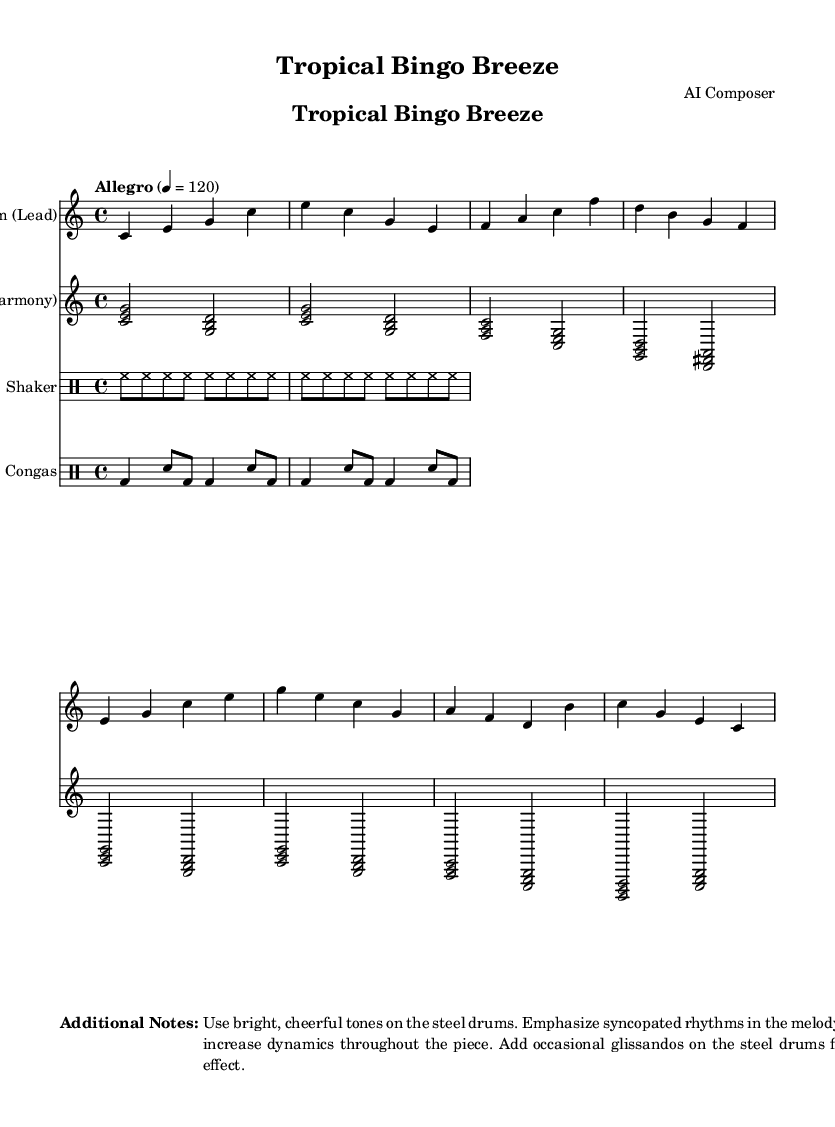What is the key signature of this music? The key signature is indicated at the beginning of the piece, which shows no sharps or flats. This means it is in C major.
Answer: C major What is the time signature of this music? The time signature is found at the beginning of the piece, represented as 4/4, indicating there are four beats in each measure and the quarter note receives one beat.
Answer: 4/4 What is the tempo marking for this piece? The tempo marking is specified near the top of the sheet music and indicates "Allegro" at a speed of 120 beats per minute.
Answer: Allegro What instruments are involved in this piece? The music includes a steel drum lead and harmony, a shaker, and congas, which are indicated by their respective staff titles.
Answer: Steel Drum, Shaker, Congas How does the melody predominantly move in this piece? Evaluating the notes in the lead part shows a mix of stepwise movement and jumps, with a noticeable emphasis on syncopation within the rhythm. It's common in steel drum music to have playful, energetic movements.
Answer: Syncopated What is a key characteristic of steel drum music as seen in this piece? Noted in the additional notes section, steel drum music often features bright tones, syncopated rhythms, and playful effects like glissandos, which are characteristics that reflect the tropical feel.
Answer: Bright, syncopated rhythms Describe the function of the shaker in this composition. The shaker’s rhythm outlined in the sheet serves to provide a steady, consistent pulse, which keeps the groove alive and complements the syncopated patterns of the steel drums, enhancing the overall tropical vibe.
Answer: Steady pulse 